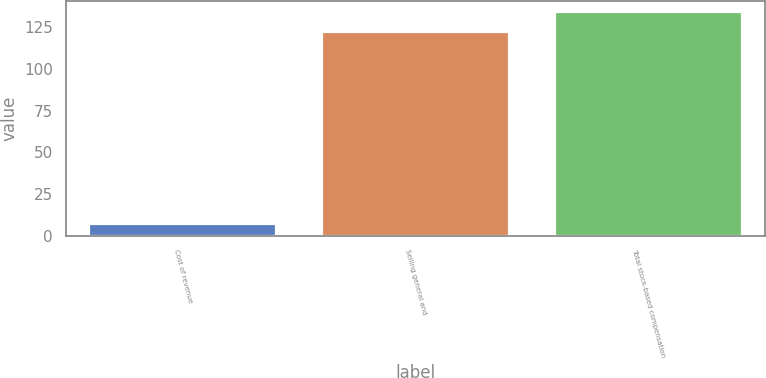Convert chart. <chart><loc_0><loc_0><loc_500><loc_500><bar_chart><fcel>Cost of revenue<fcel>Selling general and<fcel>Total stock-based compensation<nl><fcel>6.9<fcel>122<fcel>134.2<nl></chart> 